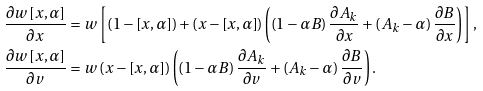<formula> <loc_0><loc_0><loc_500><loc_500>\frac { \partial w \left [ x , \alpha \right ] } { \partial x } & = w \left [ \left ( 1 - \left [ x , \alpha \right ] \right ) + \left ( x - \left [ x , \alpha \right ] \right ) \left ( \left ( 1 - \alpha B \right ) \frac { \partial A _ { k } } { \partial x } + \left ( A _ { k } - \alpha \right ) \frac { \partial B } { \partial x } \right ) \right ] \text {,} \\ \frac { \partial w \left [ x , \alpha \right ] } { \partial v } & = w \left ( x - \left [ x , \alpha \right ] \right ) \left ( \left ( 1 - \alpha B \right ) \frac { \partial A _ { k } } { \partial v } + \left ( A _ { k } - \alpha \right ) \frac { \partial B } { \partial v } \right ) .</formula> 